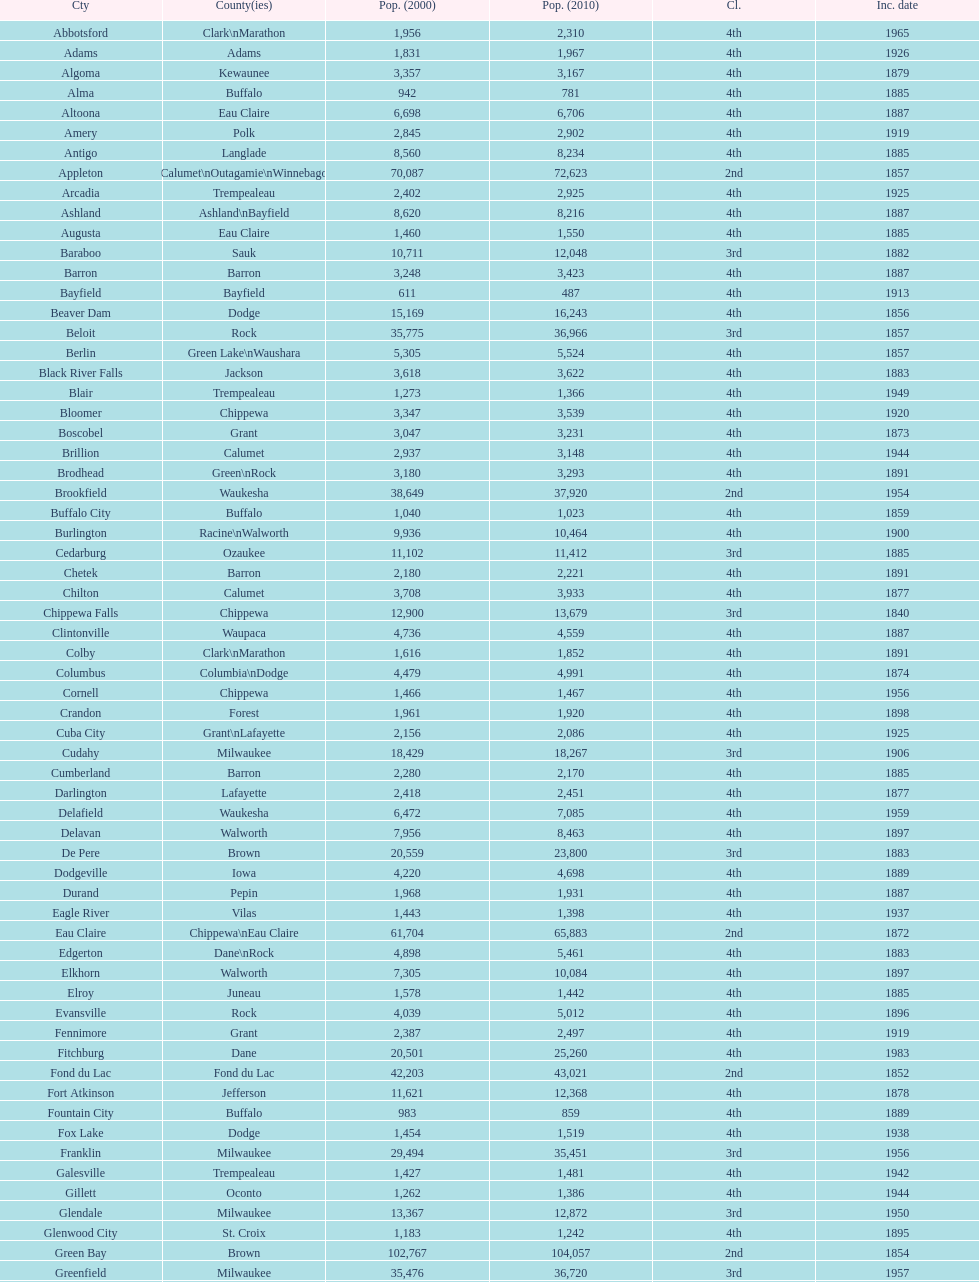What was the first city to be incorporated into wisconsin? Chippewa Falls. Would you mind parsing the complete table? {'header': ['Cty', 'County(ies)', 'Pop. (2000)', 'Pop. (2010)', 'Cl.', 'Inc. date'], 'rows': [['Abbotsford', 'Clark\\nMarathon', '1,956', '2,310', '4th', '1965'], ['Adams', 'Adams', '1,831', '1,967', '4th', '1926'], ['Algoma', 'Kewaunee', '3,357', '3,167', '4th', '1879'], ['Alma', 'Buffalo', '942', '781', '4th', '1885'], ['Altoona', 'Eau Claire', '6,698', '6,706', '4th', '1887'], ['Amery', 'Polk', '2,845', '2,902', '4th', '1919'], ['Antigo', 'Langlade', '8,560', '8,234', '4th', '1885'], ['Appleton', 'Calumet\\nOutagamie\\nWinnebago', '70,087', '72,623', '2nd', '1857'], ['Arcadia', 'Trempealeau', '2,402', '2,925', '4th', '1925'], ['Ashland', 'Ashland\\nBayfield', '8,620', '8,216', '4th', '1887'], ['Augusta', 'Eau Claire', '1,460', '1,550', '4th', '1885'], ['Baraboo', 'Sauk', '10,711', '12,048', '3rd', '1882'], ['Barron', 'Barron', '3,248', '3,423', '4th', '1887'], ['Bayfield', 'Bayfield', '611', '487', '4th', '1913'], ['Beaver Dam', 'Dodge', '15,169', '16,243', '4th', '1856'], ['Beloit', 'Rock', '35,775', '36,966', '3rd', '1857'], ['Berlin', 'Green Lake\\nWaushara', '5,305', '5,524', '4th', '1857'], ['Black River Falls', 'Jackson', '3,618', '3,622', '4th', '1883'], ['Blair', 'Trempealeau', '1,273', '1,366', '4th', '1949'], ['Bloomer', 'Chippewa', '3,347', '3,539', '4th', '1920'], ['Boscobel', 'Grant', '3,047', '3,231', '4th', '1873'], ['Brillion', 'Calumet', '2,937', '3,148', '4th', '1944'], ['Brodhead', 'Green\\nRock', '3,180', '3,293', '4th', '1891'], ['Brookfield', 'Waukesha', '38,649', '37,920', '2nd', '1954'], ['Buffalo City', 'Buffalo', '1,040', '1,023', '4th', '1859'], ['Burlington', 'Racine\\nWalworth', '9,936', '10,464', '4th', '1900'], ['Cedarburg', 'Ozaukee', '11,102', '11,412', '3rd', '1885'], ['Chetek', 'Barron', '2,180', '2,221', '4th', '1891'], ['Chilton', 'Calumet', '3,708', '3,933', '4th', '1877'], ['Chippewa Falls', 'Chippewa', '12,900', '13,679', '3rd', '1840'], ['Clintonville', 'Waupaca', '4,736', '4,559', '4th', '1887'], ['Colby', 'Clark\\nMarathon', '1,616', '1,852', '4th', '1891'], ['Columbus', 'Columbia\\nDodge', '4,479', '4,991', '4th', '1874'], ['Cornell', 'Chippewa', '1,466', '1,467', '4th', '1956'], ['Crandon', 'Forest', '1,961', '1,920', '4th', '1898'], ['Cuba City', 'Grant\\nLafayette', '2,156', '2,086', '4th', '1925'], ['Cudahy', 'Milwaukee', '18,429', '18,267', '3rd', '1906'], ['Cumberland', 'Barron', '2,280', '2,170', '4th', '1885'], ['Darlington', 'Lafayette', '2,418', '2,451', '4th', '1877'], ['Delafield', 'Waukesha', '6,472', '7,085', '4th', '1959'], ['Delavan', 'Walworth', '7,956', '8,463', '4th', '1897'], ['De Pere', 'Brown', '20,559', '23,800', '3rd', '1883'], ['Dodgeville', 'Iowa', '4,220', '4,698', '4th', '1889'], ['Durand', 'Pepin', '1,968', '1,931', '4th', '1887'], ['Eagle River', 'Vilas', '1,443', '1,398', '4th', '1937'], ['Eau Claire', 'Chippewa\\nEau Claire', '61,704', '65,883', '2nd', '1872'], ['Edgerton', 'Dane\\nRock', '4,898', '5,461', '4th', '1883'], ['Elkhorn', 'Walworth', '7,305', '10,084', '4th', '1897'], ['Elroy', 'Juneau', '1,578', '1,442', '4th', '1885'], ['Evansville', 'Rock', '4,039', '5,012', '4th', '1896'], ['Fennimore', 'Grant', '2,387', '2,497', '4th', '1919'], ['Fitchburg', 'Dane', '20,501', '25,260', '4th', '1983'], ['Fond du Lac', 'Fond du Lac', '42,203', '43,021', '2nd', '1852'], ['Fort Atkinson', 'Jefferson', '11,621', '12,368', '4th', '1878'], ['Fountain City', 'Buffalo', '983', '859', '4th', '1889'], ['Fox Lake', 'Dodge', '1,454', '1,519', '4th', '1938'], ['Franklin', 'Milwaukee', '29,494', '35,451', '3rd', '1956'], ['Galesville', 'Trempealeau', '1,427', '1,481', '4th', '1942'], ['Gillett', 'Oconto', '1,262', '1,386', '4th', '1944'], ['Glendale', 'Milwaukee', '13,367', '12,872', '3rd', '1950'], ['Glenwood City', 'St. Croix', '1,183', '1,242', '4th', '1895'], ['Green Bay', 'Brown', '102,767', '104,057', '2nd', '1854'], ['Greenfield', 'Milwaukee', '35,476', '36,720', '3rd', '1957'], ['Green Lake', 'Green Lake', '1,100', '960', '4th', '1962'], ['Greenwood', 'Clark', '1,079', '1,026', '4th', '1891'], ['Hartford', 'Dodge\\nWashington', '10,905', '14,223', '3rd', '1883'], ['Hayward', 'Sawyer', '2,129', '2,318', '4th', '1915'], ['Hillsboro', 'Vernon', '1,302', '1,417', '4th', '1885'], ['Horicon', 'Dodge', '3,775', '3,655', '4th', '1897'], ['Hudson', 'St. Croix', '8,775', '12,719', '4th', '1858'], ['Hurley', 'Iron', '1,818', '1,547', '4th', '1918'], ['Independence', 'Trempealeau', '1,244', '1,336', '4th', '1942'], ['Janesville', 'Rock', '59,498', '63,575', '2nd', '1853'], ['Jefferson', 'Jefferson', '7,338', '7,973', '4th', '1878'], ['Juneau', 'Dodge', '2,485', '2,814', '4th', '1887'], ['Kaukauna', 'Outagamie', '12,983', '15,462', '3rd', '1885'], ['Kenosha', 'Kenosha', '90,352', '99,218', '2nd', '1850'], ['Kewaunee', 'Kewaunee', '2,806', '2,952', '4th', '1883'], ['Kiel', 'Calumet\\nManitowoc', '3,450', '3,738', '4th', '1920'], ['La Crosse', 'La Crosse', '51,818', '51,320', '2nd', '1856'], ['Ladysmith', 'Rusk', '3,932', '3,414', '4th', '1905'], ['Lake Geneva', 'Walworth', '7,148', '7,651', '4th', '1883'], ['Lake Mills', 'Jefferson', '4,843', '5,708', '4th', '1905'], ['Lancaster', 'Grant', '4,070', '3,868', '4th', '1878'], ['Lodi', 'Columbia', '2,882', '3,050', '4th', '1941'], ['Loyal', 'Clark', '1,308', '1,261', '4th', '1948'], ['Madison', 'Dane', '208,054', '233,209', '2nd', '1856'], ['Manawa', 'Waupaca', '1,330', '1,371', '4th', '1954'], ['Manitowoc', 'Manitowoc', '34,053', '33,736', '3rd', '1870'], ['Marinette', 'Marinette', '11,749', '10,968', '3rd', '1887'], ['Marion', 'Shawano\\nWaupaca', '1,297', '1,260', '4th', '1898'], ['Markesan', 'Green Lake', '1,396', '1,476', '4th', '1959'], ['Marshfield', 'Marathon\\nWood', '18,800', '19,118', '3rd', '1883'], ['Mauston', 'Juneau', '3,740', '4,423', '4th', '1883'], ['Mayville', 'Dodge', '4,902', '5,154', '4th', '1885'], ['Medford', 'Taylor', '4,350', '4,326', '4th', '1889'], ['Mellen', 'Ashland', '845', '731', '4th', '1907'], ['Menasha', 'Calumet\\nWinnebago', '16,331', '17,353', '3rd', '1874'], ['Menomonie', 'Dunn', '14,937', '16,264', '4th', '1882'], ['Mequon', 'Ozaukee', '22,643', '23,132', '4th', '1957'], ['Merrill', 'Lincoln', '10,146', '9,661', '4th', '1883'], ['Middleton', 'Dane', '15,770', '17,442', '3rd', '1963'], ['Milton', 'Rock', '5,132', '5,546', '4th', '1969'], ['Milwaukee', 'Milwaukee\\nWashington\\nWaukesha', '596,974', '594,833', '1st', '1846'], ['Mineral Point', 'Iowa', '2,617', '2,487', '4th', '1857'], ['Mondovi', 'Buffalo', '2,634', '2,777', '4th', '1889'], ['Monona', 'Dane', '8,018', '7,533', '4th', '1969'], ['Monroe', 'Green', '10,843', '10,827', '4th', '1882'], ['Montello', 'Marquette', '1,397', '1,495', '4th', '1938'], ['Montreal', 'Iron', '838', '807', '4th', '1924'], ['Mosinee', 'Marathon', '4,063', '3,988', '4th', '1931'], ['Muskego', 'Waukesha', '21,397', '24,135', '3rd', '1964'], ['Neenah', 'Winnebago', '24,507', '25,501', '3rd', '1873'], ['Neillsville', 'Clark', '2,731', '2,463', '4th', '1882'], ['Nekoosa', 'Wood', '2,590', '2,580', '4th', '1926'], ['New Berlin', 'Waukesha', '38,220', '39,584', '3rd', '1959'], ['New Holstein', 'Calumet', '3,301', '3,236', '4th', '1889'], ['New Lisbon', 'Juneau', '1,436', '2,554', '4th', '1889'], ['New London', 'Outagamie\\nWaupaca', '7,085', '7,295', '4th', '1877'], ['New Richmond', 'St. Croix', '6,310', '8,375', '4th', '1885'], ['Niagara', 'Marinette', '1,880', '1,624', '4th', '1992'], ['Oak Creek', 'Milwaukee', '28,456', '34,451', '3rd', '1955'], ['Oconomowoc', 'Waukesha', '12,382', '15,712', '3rd', '1875'], ['Oconto', 'Oconto', '4,708', '4,513', '4th', '1869'], ['Oconto Falls', 'Oconto', '2,843', '2,891', '4th', '1919'], ['Omro', 'Winnebago', '3,177', '3,517', '4th', '1944'], ['Onalaska', 'La Crosse', '14,839', '17,736', '4th', '1887'], ['Oshkosh', 'Winnebago', '62,916', '66,083', '2nd', '1853'], ['Osseo', 'Trempealeau', '1,669', '1,701', '4th', '1941'], ['Owen', 'Clark', '936', '940', '4th', '1925'], ['Park Falls', 'Price', '2,739', '2,462', '4th', '1912'], ['Peshtigo', 'Marinette', '3,474', '3,502', '4th', '1903'], ['Pewaukee', 'Waukesha', '11,783', '13,195', '3rd', '1999'], ['Phillips', 'Price', '1,675', '1,478', '4th', '1891'], ['Pittsville', 'Wood', '866', '874', '4th', '1887'], ['Platteville', 'Grant', '9,989', '11,224', '4th', '1876'], ['Plymouth', 'Sheboygan', '7,781', '8,445', '4th', '1877'], ['Port Washington', 'Ozaukee', '10,467', '11,250', '4th', '1882'], ['Portage', 'Columbia', '9,728', '10,324', '4th', '1854'], ['Prairie du Chien', 'Crawford', '6,018', '5,911', '4th', '1872'], ['Prescott', 'Pierce', '3,764', '4,258', '4th', '1857'], ['Princeton', 'Green Lake', '1,504', '1,214', '4th', '1920'], ['Racine', 'Racine', '81,855', '78,860', '2nd', '1848'], ['Reedsburg', 'Sauk', '7,827', '10,014', '4th', '1887'], ['Rhinelander', 'Oneida', '7,735', '7,798', '4th', '1894'], ['Rice Lake', 'Barron', '8,312', '8,438', '4th', '1887'], ['Richland Center', 'Richland', '5,114', '5,184', '4th', '1887'], ['Ripon', 'Fond du Lac', '7,450', '7,733', '4th', '1858'], ['River Falls', 'Pierce\\nSt. Croix', '12,560', '15,000', '3rd', '1875'], ['St. Croix Falls', 'Polk', '2,033', '2,133', '4th', '1958'], ['St. Francis', 'Milwaukee', '8,662', '9,365', '4th', '1951'], ['Schofield', 'Marathon', '2,117', '2,169', '4th', '1951'], ['Seymour', 'Outagamie', '3,335', '3,451', '4th', '1879'], ['Shawano', 'Shawano', '8,298', '9,305', '4th', '1874'], ['Sheboygan', 'Sheboygan', '50,792', '49,288', '2nd', '1853'], ['Sheboygan Falls', 'Sheboygan', '6,772', '7,775', '4th', '1913'], ['Shell Lake', 'Washburn', '1,309', '1,347', '4th', '1961'], ['Shullsburg', 'Lafayette', '1,246', '1,226', '4th', '1889'], ['South Milwaukee', 'Milwaukee', '21,256', '21,156', '4th', '1897'], ['Sparta', 'Monroe', '8,648', '9,522', '4th', '1883'], ['Spooner', 'Washburn', '2,653', '2,682', '4th', '1909'], ['Stanley', 'Chippewa\\nClark', '1,898', '3,608', '4th', '1898'], ['Stevens Point', 'Portage', '24,551', '26,717', '3rd', '1858'], ['Stoughton', 'Dane', '12,354', '12,611', '4th', '1882'], ['Sturgeon Bay', 'Door', '9,437', '9,144', '4th', '1883'], ['Sun Prairie', 'Dane', '20,369', '29,364', '3rd', '1958'], ['Superior', 'Douglas', '27,368', '27,244', '2nd', '1858'], ['Thorp', 'Clark', '1,536', '1,621', '4th', '1948'], ['Tomah', 'Monroe', '8,419', '9,093', '4th', '1883'], ['Tomahawk', 'Lincoln', '3,770', '3,397', '4th', '1891'], ['Two Rivers', 'Manitowoc', '12,639', '11,712', '3rd', '1878'], ['Verona', 'Dane', '7,052', '10,619', '4th', '1977'], ['Viroqua', 'Vernon', '4,335', '5,079', '4th', '1885'], ['Washburn', 'Bayfield', '2,280', '2,117', '4th', '1904'], ['Waterloo', 'Jefferson', '3,259', '3,333', '4th', '1962'], ['Watertown', 'Dodge\\nJefferson', '21,598', '23,861', '3rd', '1853'], ['Waukesha', 'Waukesha', '64,825', '70,718', '2nd', '1895'], ['Waupaca', 'Waupaca', '5,676', '6,069', '4th', '1878'], ['Waupun', 'Dodge\\nFond du Lac', '10,944', '11,340', '4th', '1878'], ['Wausau', 'Marathon', '38,426', '39,106', '3rd', '1872'], ['Wautoma', 'Waushara', '1,998', '2,218', '4th', '1901'], ['Wauwatosa', 'Milwaukee', '47,271', '46,396', '2nd', '1897'], ['West Allis', 'Milwaukee', '61,254', '60,411', '2nd', '1906'], ['West Bend', 'Washington', '28,152', '31,078', '3rd', '1885'], ['Westby', 'Vernon', '2,045', '2,200', '4th', '1920'], ['Weyauwega', 'Waupaca', '1,806', '1,900', '4th', '1939'], ['Whitehall', 'Trempealeau', '1,651', '1,558', '4th', '1941'], ['Whitewater', 'Jefferson\\nWalworth', '13,437', '14,390', '4th', '1885'], ['Wisconsin Dells', 'Adams\\nColumbia\\nJuneau\\nSauk', '2,418', '2,678', '4th', '1925'], ['Wisconsin Rapids', 'Wood', '18,435', '18,367', '3rd', '1869']]} 